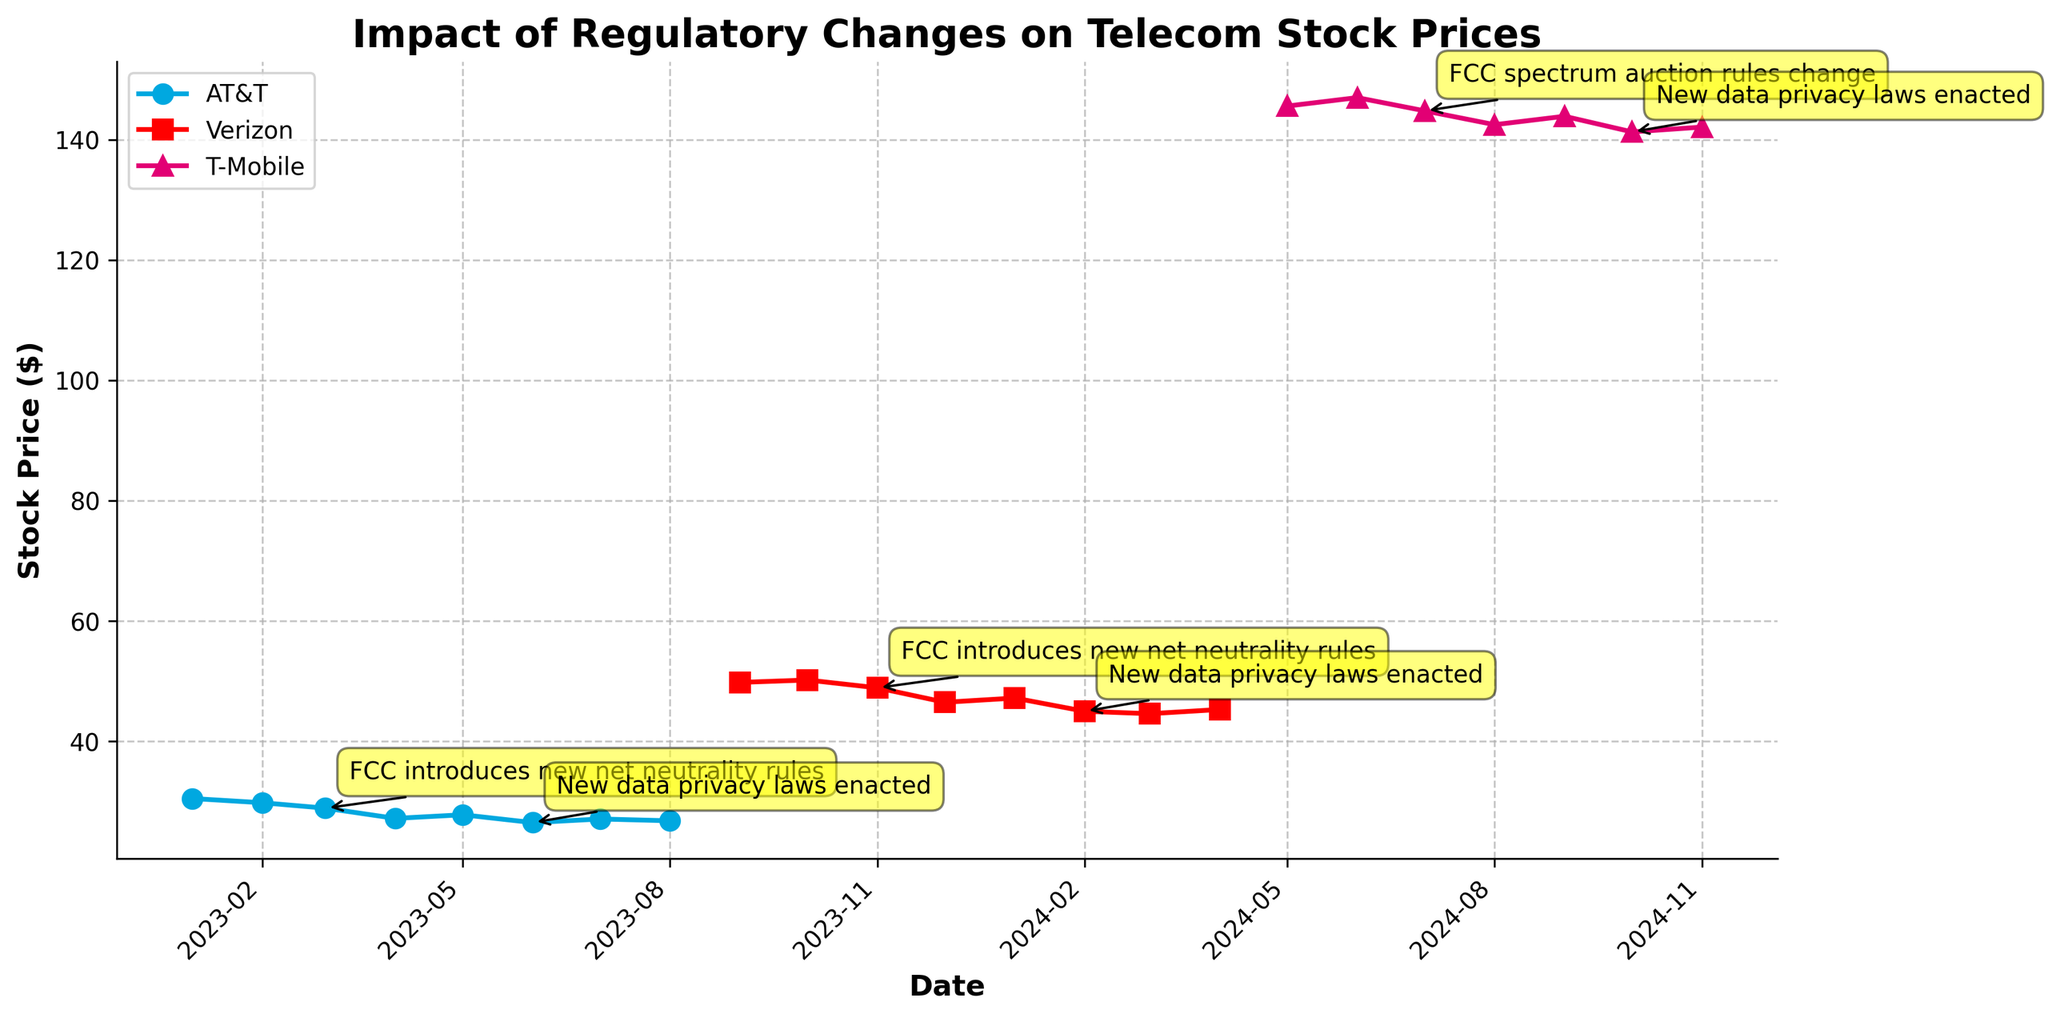What is the title of the plot? The title of the plot is usually displayed at the top and centered. By looking at the plot, the title reads "Impact of Regulatory Changes on Telecom Stock Prices."
Answer: Impact of Regulatory Changes on Telecom Stock Prices Which company has the highest closing stock price in the data? By examining the different lines and their corresponding labels, T-Mobile has the highest closing stock price according to the figure.
Answer: T-Mobile How many regulatory changes impacted AT&T according to the plot? By looking for annotations on the plot specifically for AT&T (color-coded in blue), we can identify three regulatory changes affecting AT&T.
Answer: Three What was the impact of the FCC introducing new net neutrality rules on Verizon's stock price? Observing the stock price line for Verizon before and after the FCC introducing new net neutrality rules annotation, it shows a decrease from $50.20 to $48.90.
Answer: Decrease Compare the trends of AT&T and Verizon after the new data privacy laws were enacted. After the regulatory event on AT&T and Verizon, marked by the annotations on 2023-06-01 and 2024-02-01, AT&T's stock price showed a slight increase from $26.50 to $27.10, whereas Verizon's stock price continued to decline from $45.00 to $44.60.
Answer: AT&T increased, Verizon decreased When did T-Mobile experience a significant stock price drop before the new data privacy laws? An annotation shows T-Mobile experienced a notable drop in stock price from $147.00 to $144.80 on 2024-07-01 due to the FCC spectrum auction rules change.
Answer: 2024-07-01 Which regulatory change appears closest to the beginning of 2024? Checking the dates and associated annotations, Verizon was affected by new data privacy laws on 2024-02-01.
Answer: New data privacy laws Between June 2023 and November 2023, how has Verizon's stock price changed? Reviewing the dates and stock prices, Verizon's stock price decreased from $49.80 in June 2023 to $48.90 in November 2023.
Answer: Decreased How did T-Mobile's stock price move after the FCC spectrum auction rules change? After the FCC spectrum auction rules change annotation on 2024-07-01, T-Mobile's stock price shows a decline from $144.80 to $142.50.
Answer: Decline What general trend can be observed in AT&T's stock price from January 2023 to August 2023? Observing the plotted line for AT&T (blue line) from January 2023 to August 2023, there is a general downtrend from $30.50 to $26.80.
Answer: Downtrend 